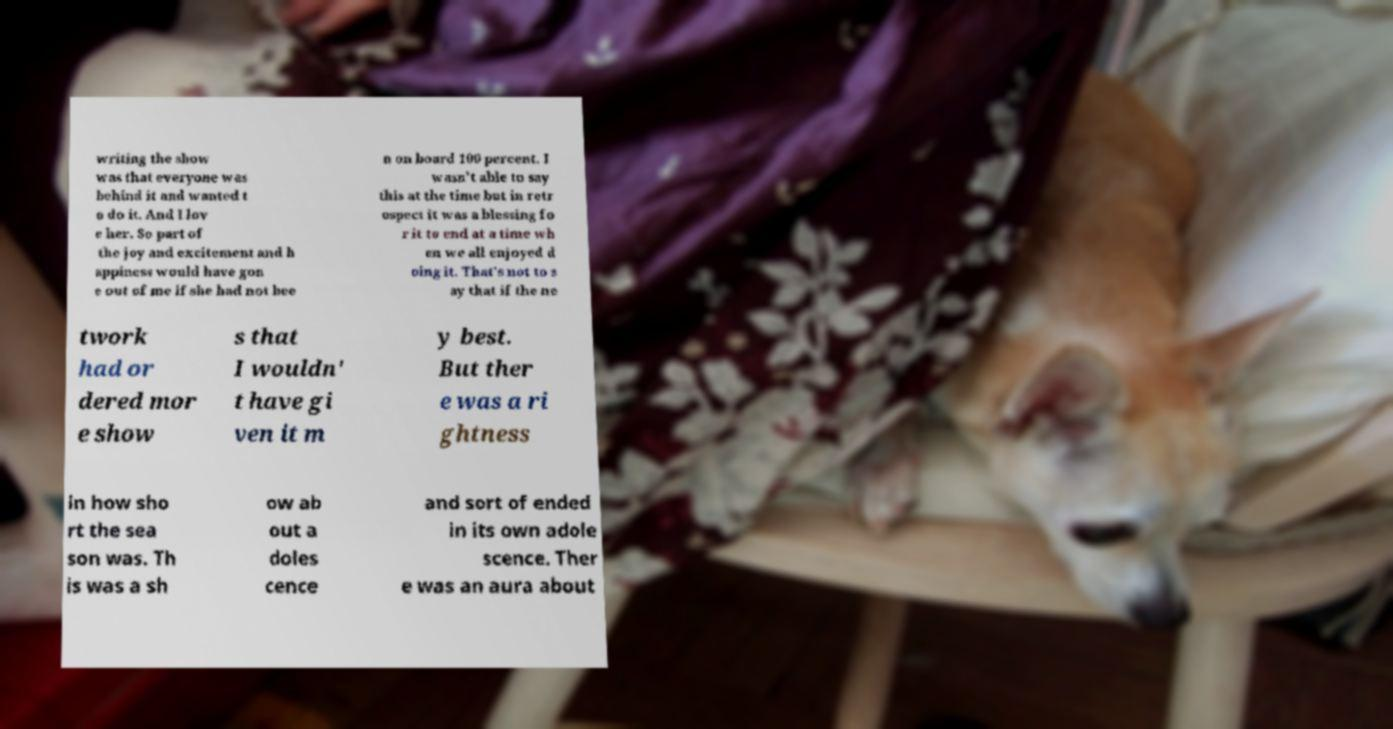What messages or text are displayed in this image? I need them in a readable, typed format. writing the show was that everyone was behind it and wanted t o do it. And I lov e her. So part of the joy and excitement and h appiness would have gon e out of me if she had not bee n on board 100 percent. I wasn't able to say this at the time but in retr ospect it was a blessing fo r it to end at a time wh en we all enjoyed d oing it. That's not to s ay that if the ne twork had or dered mor e show s that I wouldn' t have gi ven it m y best. But ther e was a ri ghtness in how sho rt the sea son was. Th is was a sh ow ab out a doles cence and sort of ended in its own adole scence. Ther e was an aura about 